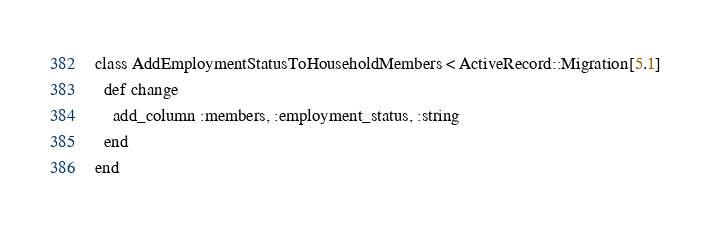Convert code to text. <code><loc_0><loc_0><loc_500><loc_500><_Ruby_>class AddEmploymentStatusToHouseholdMembers < ActiveRecord::Migration[5.1]
  def change
    add_column :members, :employment_status, :string
  end
end
</code> 